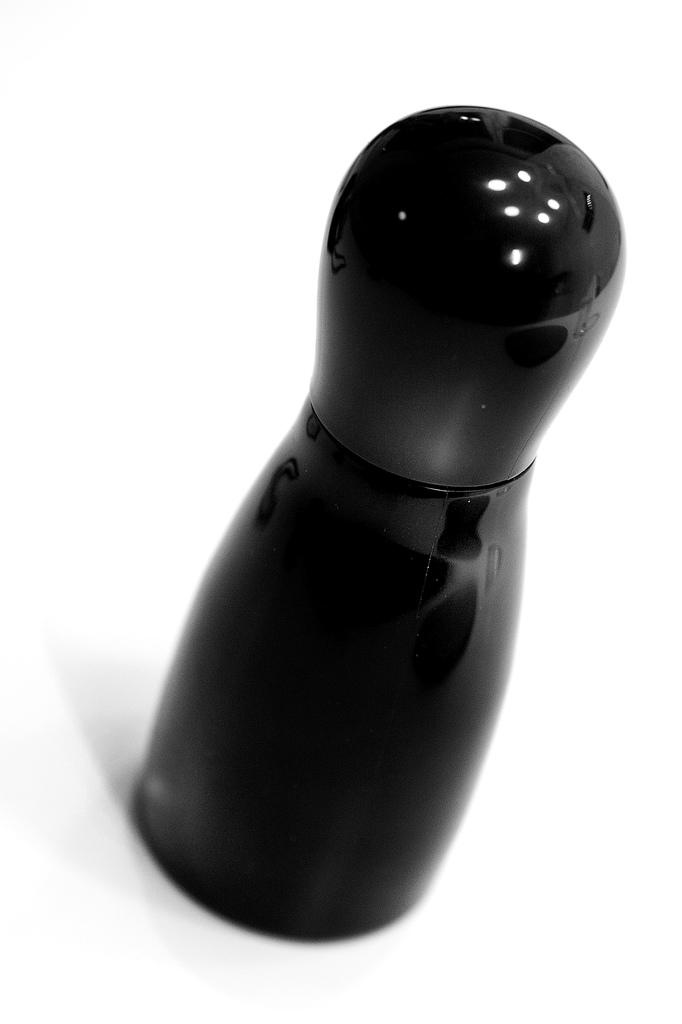What color is the bottle that is visible in the image? There is a black color bottle in the image. How many police officers are present in the image? There are no police officers present in the image; it only features a black color bottle. What type of dust can be seen on the bottle in the image? There is no dust visible on the bottle in the image. 